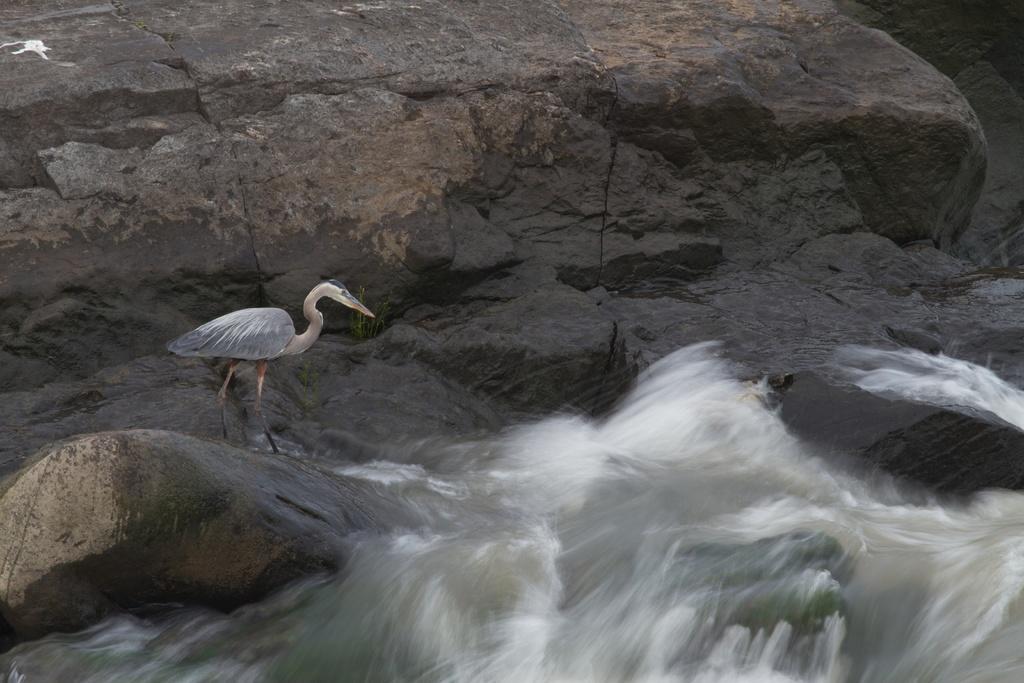How would you summarize this image in a sentence or two? In this image I can see a bird which is black, white and cream in color is standing on a rock. I can see some water and a huge rock surface. 